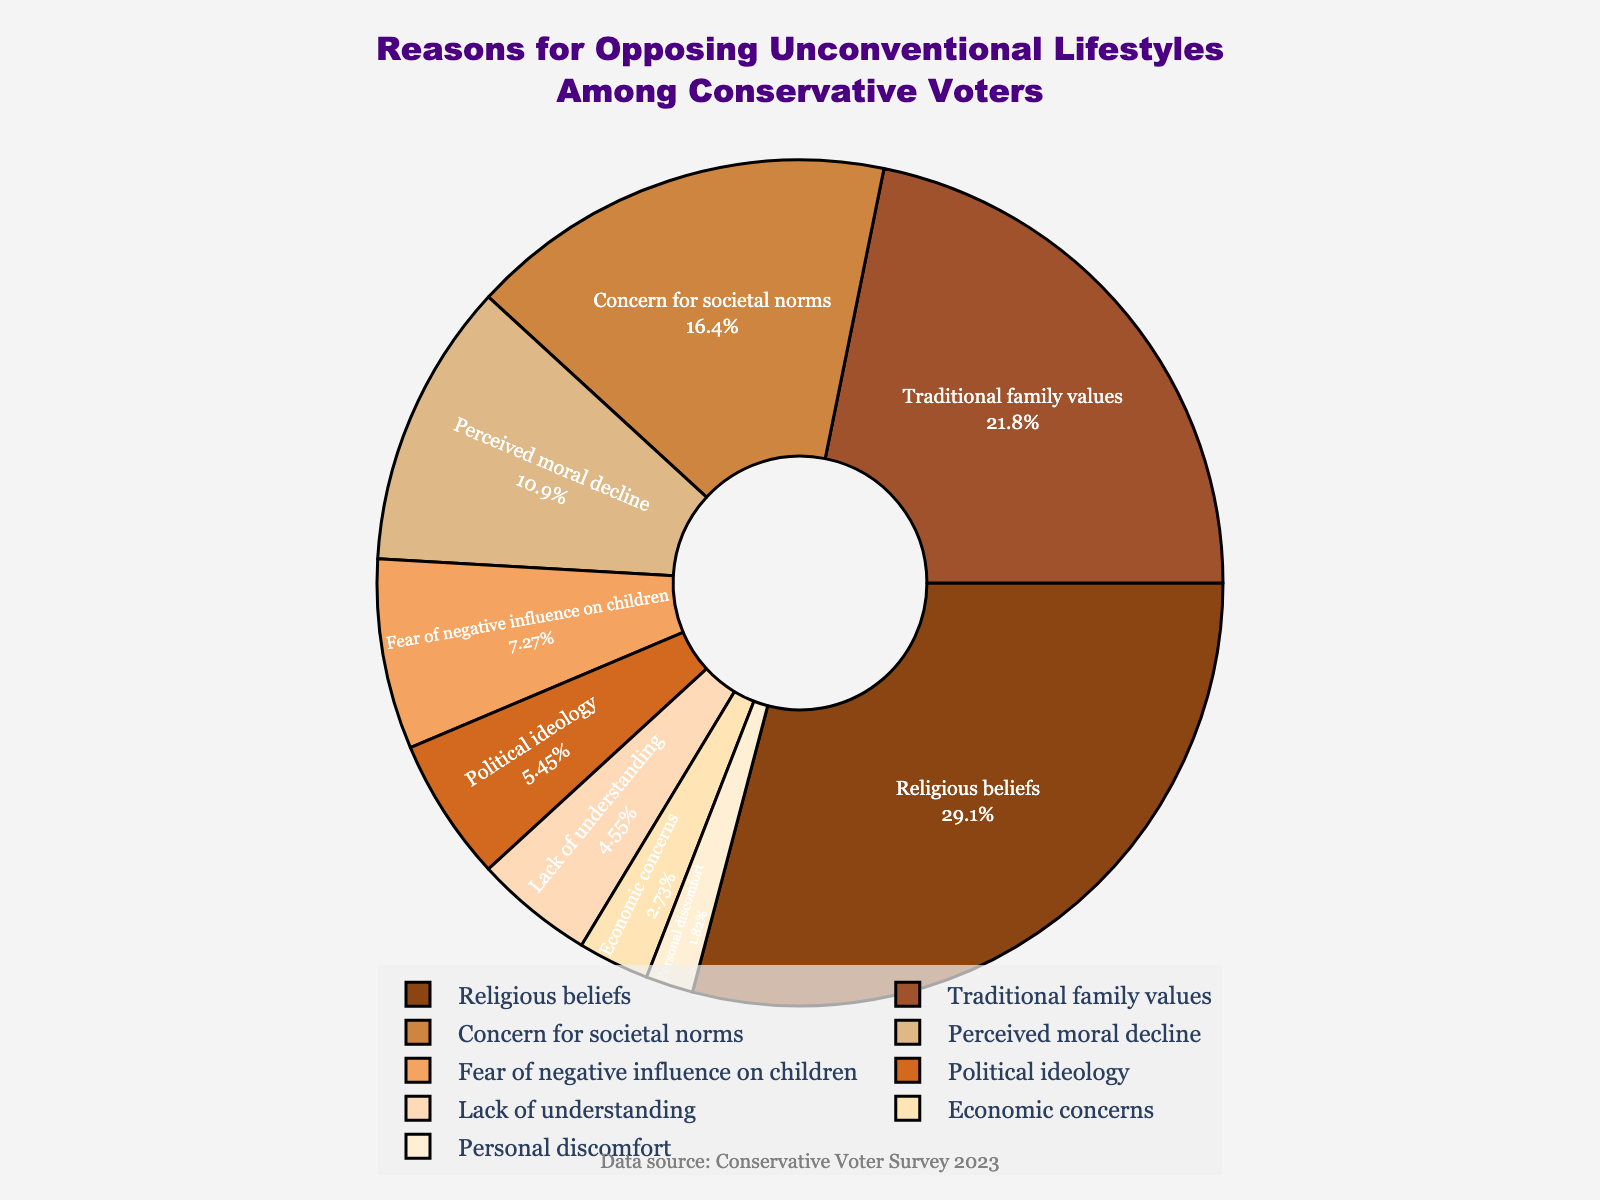What is the most cited reason for opposing unconventional lifestyles among conservative voters? The largest slice on the pie chart, which is in brown and takes up 32%, represents "Religious beliefs" as the most cited reason.
Answer: Religious beliefs What is the combined percentage of "Traditional family values" and "Concern for societal norms"? "Traditional family values" makes up 24%, and "Concern for societal norms" is 18%. Adding these two values together gives 24% + 18% = 42%.
Answer: 42% Which reasons cited for opposing unconventional lifestyles have a percentage lower than 10%? The pie chart segments for "Fear of negative influence on children" (8%), "Political ideology" (6%), "Lack of understanding" (5%), "Economic concerns" (3%), and "Personal discomfort" (2%) are smaller, making them less than 10%.
Answer: Fear of negative influence on children, Political ideology, Lack of understanding, Economic concerns, Personal discomfort How much higher is the percentage of "Concern for societal norms" compared to "Fear of negative influence on children"? The percentage of "Concern for societal norms" is 18%, and for "Fear of negative influence on children" it is 8%. The difference is 18% - 8% = 10%.
Answer: 10% What is the total percentage of the reasons cited that are directly related to moral or ethical concerns (i.e., "Perceived moral decline" and "Religious beliefs")? "Perceived moral decline" accounts for 12%, and "Religious beliefs" account for 32%. Adding these together gives 12% + 32% = 44%.
Answer: 44% Is "Economic concerns" cited more frequently than "Personal discomfort"? According to the pie chart, "Economic concerns" are 3%, whereas "Personal discomfort" is 2%. Since 3% is greater than 2%, "Economic concerns" is cited more frequently.
Answer: Yes Which reasons have been cited by more than 20% of voters? The pie chart shows that "Religious beliefs" (32%) and "Traditional family values" (24%) are cited by more than 20%.
Answer: Religious beliefs, Traditional family values What is the sum percentage of all reasons cited? Summing all the percentages given: 32% + 24% + 18% + 12% + 8% + 6% + 5% + 3% + 2% = 110%. This suggests there may be a discrepancy in the data provided, as the total exceeds 100%.
Answer: 110% 